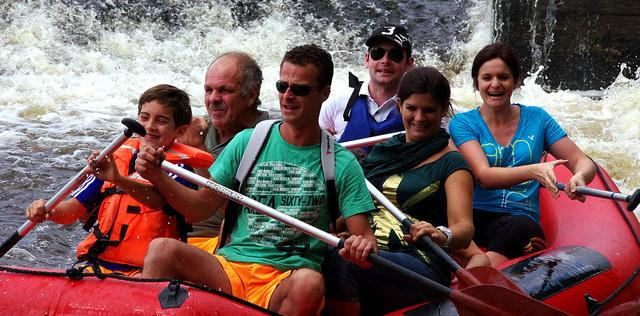What safety item is the person in Green and blue shirts missing? Please explain your reasoning. life vest. The person in green doesn't have a life vest. 